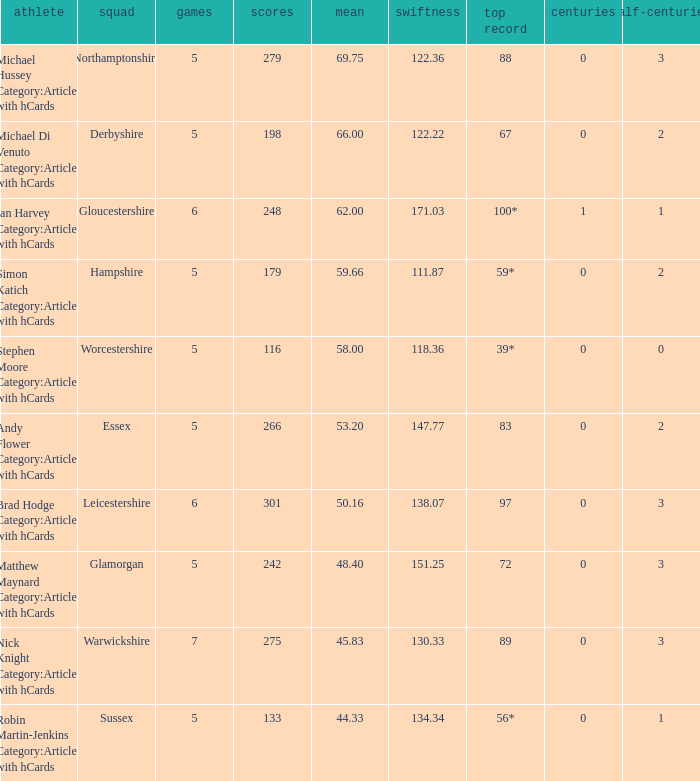If the top score is 88, what are the 50s? 3.0. 